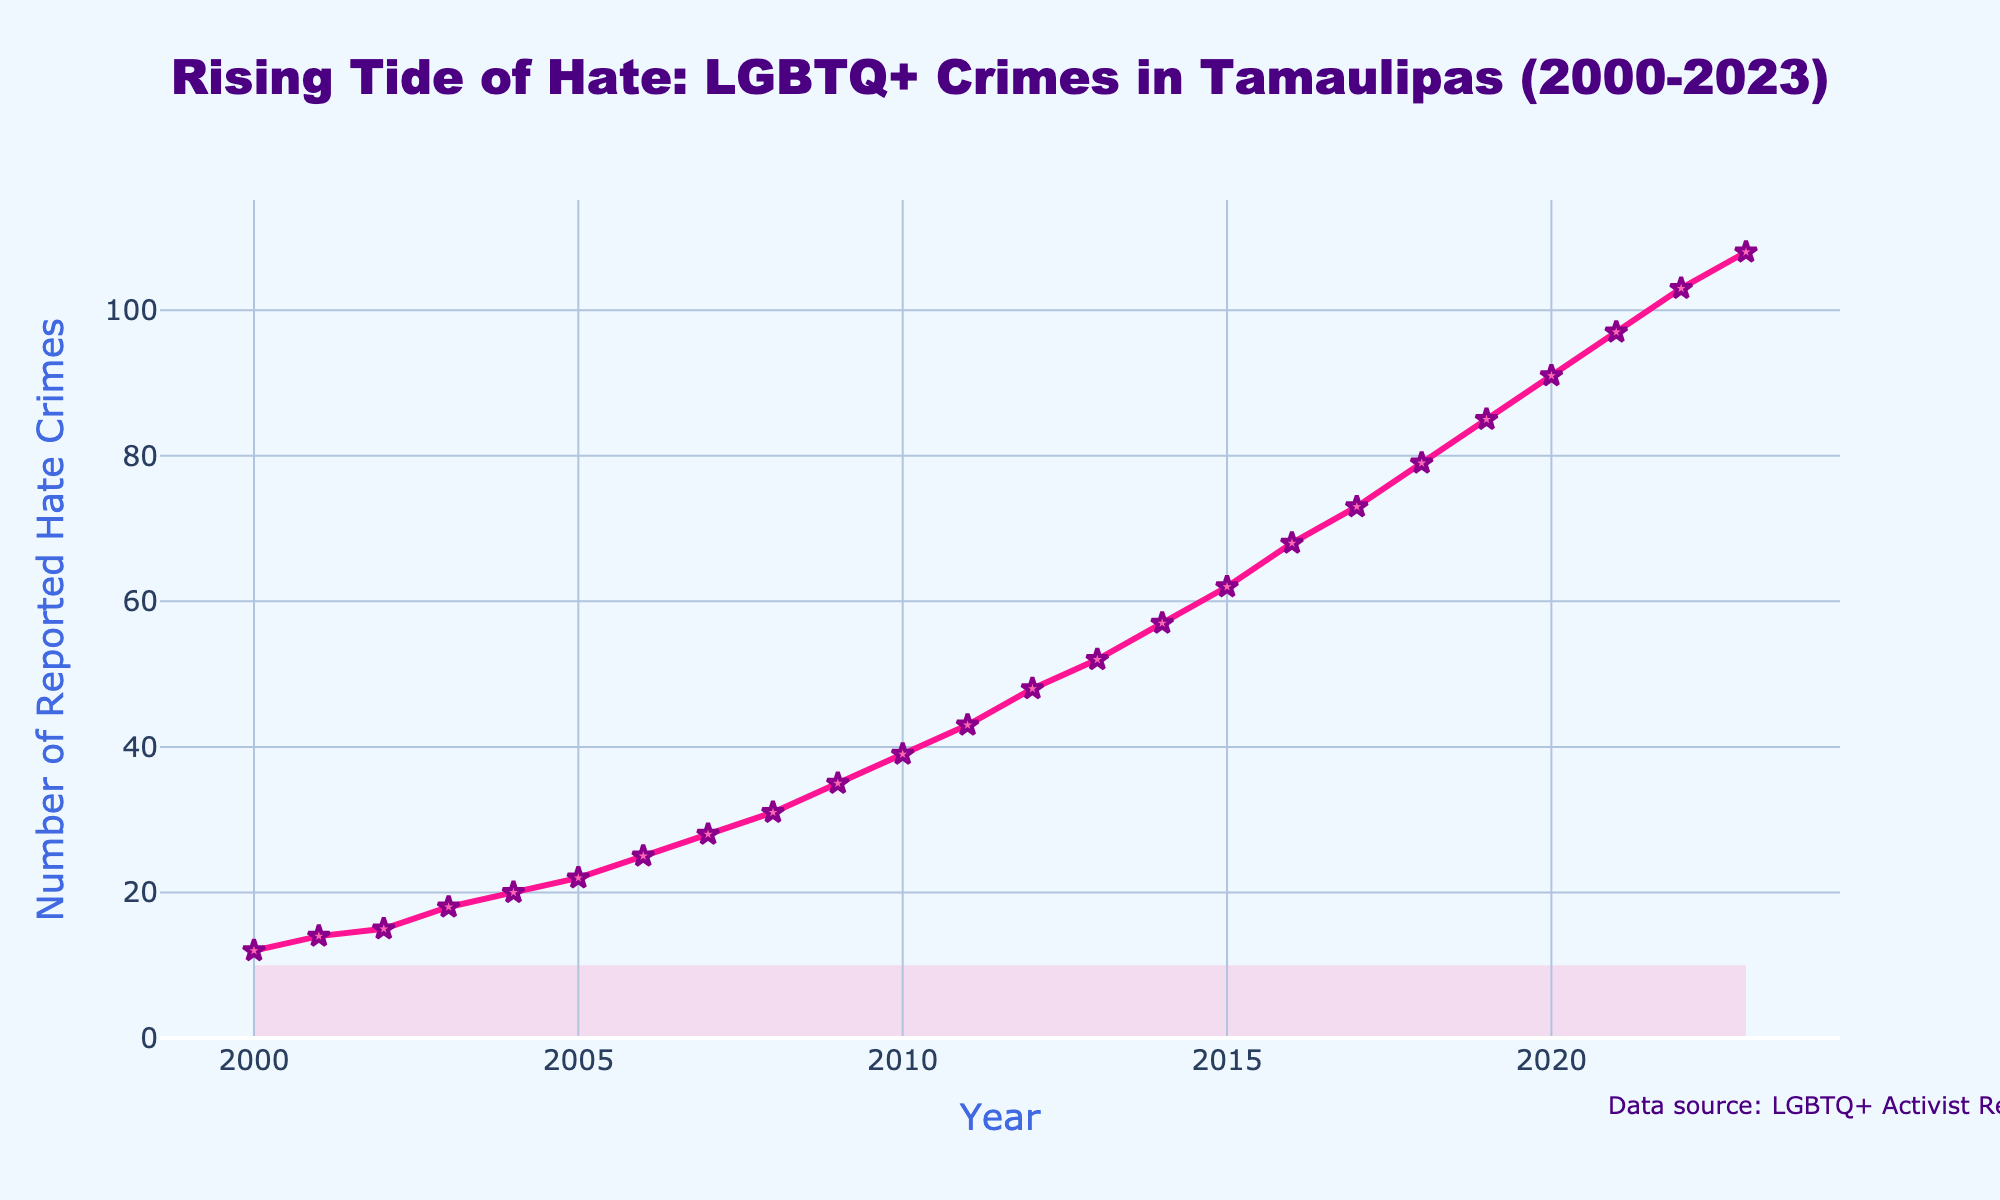What's the total number of reported hate crimes from 2000 to 2023? Sum the reported hate crimes from each year: 12 + 14 + 15 + 18 + 20 + 22 + 25 + 28 + 31 + 35 + 39 + 43 + 48 + 52 + 57 + 62 + 68 + 73 + 79 + 85 + 91 + 97 + 103 + 108 = 1161
Answer: 1161 In which year did the number of reported hate crimes first surpass 50? Examine the line chart and identify the year where the data first exceeds 50. In 2013, the reported hate crimes are 52, which is the first time the number surpasses 50.
Answer: 2013 How does the increase in reported hate crimes between 2010 and 2020 compare to the increase between 2000 and 2010? Calculate the difference in reported hate crimes for each period: From 2000 to 2010: 39 - 12 = 27. From 2010 to 2020: 91 - 39 = 52. Comparing both, there was a larger increase between 2010 and 2020.
Answer: 52 vs 27 What is the average annual increase in reported hate crimes over the entire period? Calculate the total increase from 2000 to 2023, which is 108 - 12 = 96. Then divide by the number of intervals (2023 - 2000 = 23): 96 / 23 ≈ 4.17
Answer: 4.17 Which year saw the highest annual increase in reported hate crimes? Look for the year-to-year differences and identify the largest one. From 2016 to 2017, the increase was 73 - 68 = 5, and this pattern continues similarly, but the increase between 2011 and 2012 is 48 - 43 = 5 among many years showing consistent and considerable increments.
Answer: 5 (multiple years) What is the color of the line representing the reported hate crimes? Clearly observe the colored line in the plot; it's described as pink.
Answer: Pink Which years had an identical number of reported hate crimes either increasing or decreasing value by 5? Check the reported hate crimes increase to find any transitions that are consistently increasing by 5. Years like 2008 to 2009: 35-31, 2009 to 2010: 39-35, 2012 to 2013: 52-48, 2013 to 2014: 57-52 have increments by 5 difference.
Answer: 2007-2008, 2008-2009, 2016-2017, and 2021-2022 What is the title of the plot that describes the data? Examine the plot's title, it's stated as 'Rising Tide of Hate: LGBTQ+ Crimes in Tamaulipas (2000-2023)'.
Answer: Rising Tide of Hate: LGBTQ+ Crimes in Tamaulipas (2000-2023) How many years saw an increase in reported hate crimes compared to the previous year? Count the number of years where the number of reported hate crimes is higher than in the previous year. All years from 2000 to 2023 show an increase.
Answer: 23 What's the total number of reported hate crimes from 2000 to 2010 and compare it to the total from 2010 to 2020? Sum the reported hate crimes from 2000 to 2010: 12 + 14 + 15 + 18 + 20 + 22 + 25 + 28 + 31 + 35 + 39 = 259. Sum the hate crimes from 2010 to 2020: 39 + 43 + 48 + 52 + 57 + 62 + 68 + 73 + 79 + 85 + 91 = 697. Compare both totals: 697 is significantly higher than 259.
Answer: 697 vs 259 